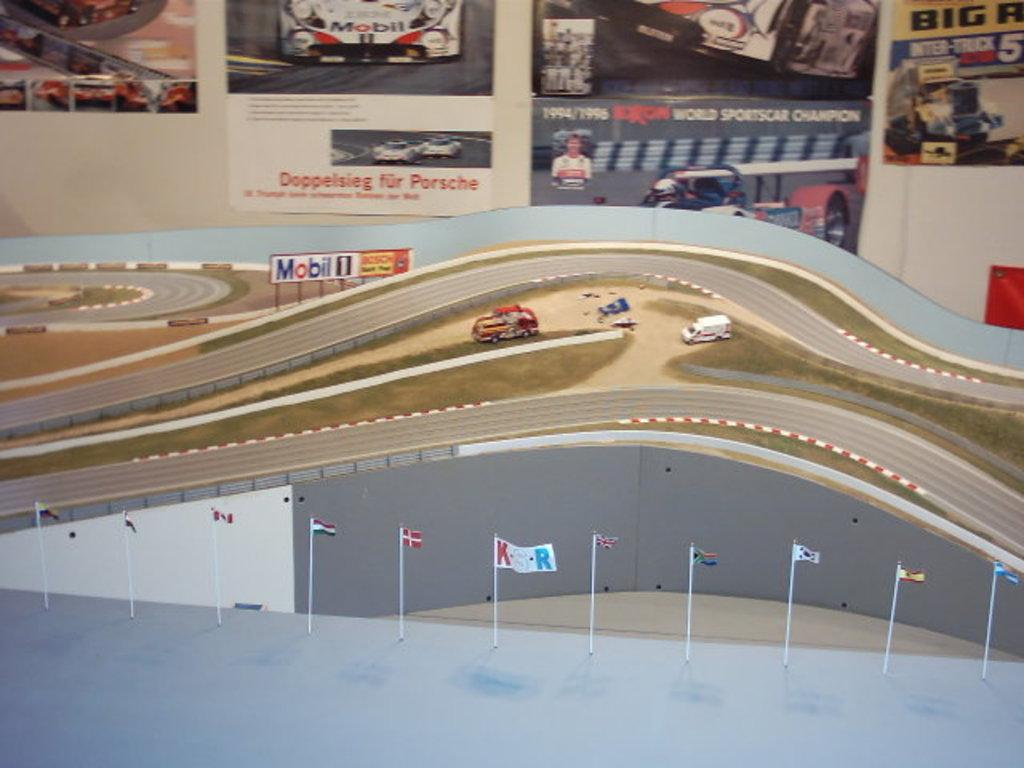What is the main subject of the image? The main subject of the image is a design of a road. What else can be seen in the image besides the road? There are vehicles, a hoarding, grass, flags on a platform, and posters on a platform in the background. How many dogs are present in the image? There are no dogs present in the image. What type of brake is installed on the vehicles in the image? The image does not provide information about the type of brake installed on the vehicles. 